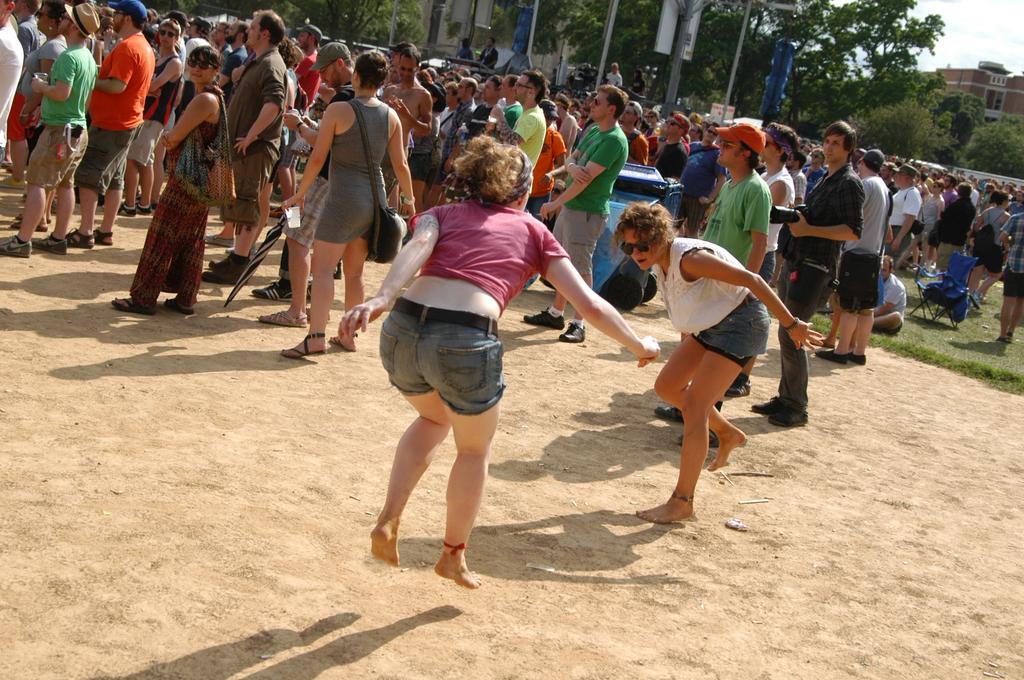How would you summarize this image in a sentence or two? There are two women playing on the ground. In the background, there are other persons on the ground, there is a person sitting on the grass on the ground, there are trees, buildings and clouds in the blue sky. 